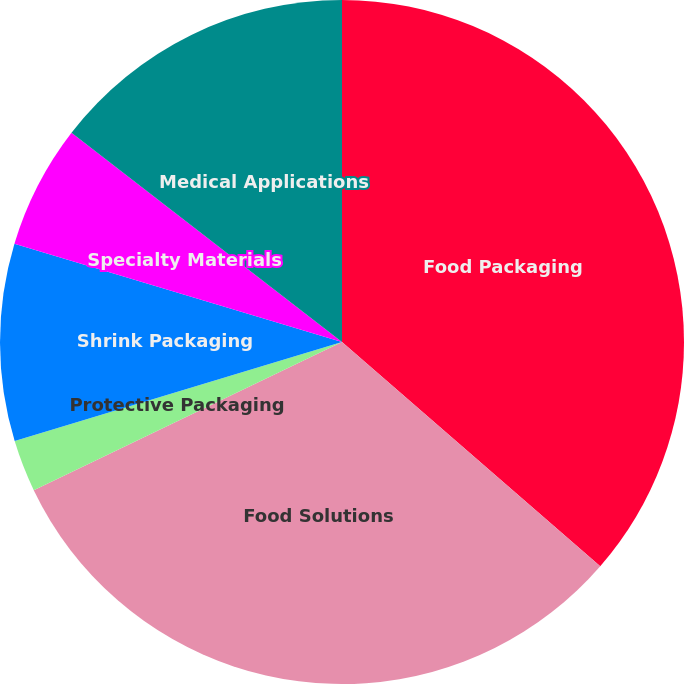Convert chart. <chart><loc_0><loc_0><loc_500><loc_500><pie_chart><fcel>Food Packaging<fcel>Food Solutions<fcel>Protective Packaging<fcel>Shrink Packaging<fcel>Specialty Materials<fcel>Medical Applications<nl><fcel>36.38%<fcel>31.49%<fcel>2.45%<fcel>9.32%<fcel>5.84%<fcel>14.52%<nl></chart> 